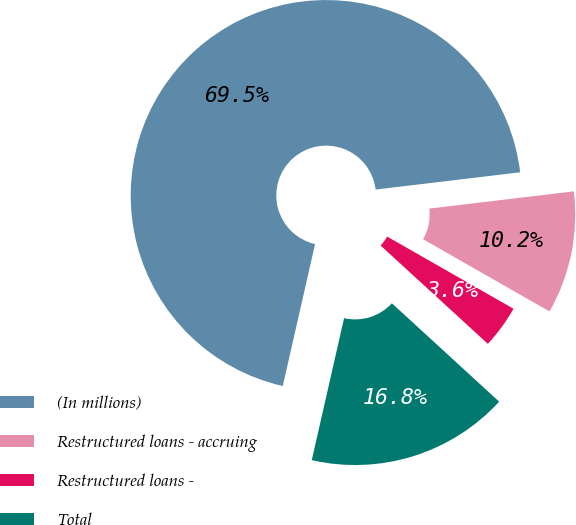<chart> <loc_0><loc_0><loc_500><loc_500><pie_chart><fcel>(In millions)<fcel>Restructured loans - accruing<fcel>Restructured loans -<fcel>Total<nl><fcel>69.54%<fcel>10.15%<fcel>3.55%<fcel>16.75%<nl></chart> 